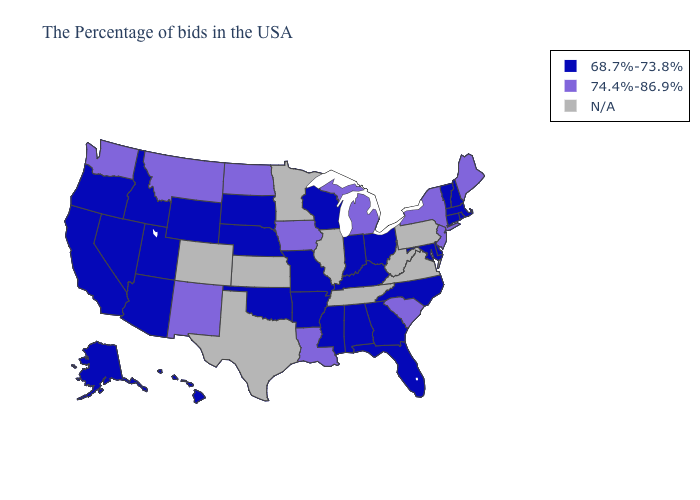Among the states that border South Dakota , which have the highest value?
Give a very brief answer. Iowa, North Dakota, Montana. Name the states that have a value in the range 68.7%-73.8%?
Be succinct. Massachusetts, Rhode Island, New Hampshire, Vermont, Connecticut, Delaware, Maryland, North Carolina, Ohio, Florida, Georgia, Kentucky, Indiana, Alabama, Wisconsin, Mississippi, Missouri, Arkansas, Nebraska, Oklahoma, South Dakota, Wyoming, Utah, Arizona, Idaho, Nevada, California, Oregon, Alaska, Hawaii. Among the states that border Florida , which have the lowest value?
Concise answer only. Georgia, Alabama. Does Nebraska have the highest value in the MidWest?
Short answer required. No. Name the states that have a value in the range N/A?
Quick response, please. Pennsylvania, Virginia, West Virginia, Tennessee, Illinois, Minnesota, Kansas, Texas, Colorado. Is the legend a continuous bar?
Write a very short answer. No. Which states have the highest value in the USA?
Give a very brief answer. Maine, New York, New Jersey, South Carolina, Michigan, Louisiana, Iowa, North Dakota, New Mexico, Montana, Washington. Which states hav the highest value in the Northeast?
Short answer required. Maine, New York, New Jersey. Name the states that have a value in the range N/A?
Quick response, please. Pennsylvania, Virginia, West Virginia, Tennessee, Illinois, Minnesota, Kansas, Texas, Colorado. What is the lowest value in the USA?
Quick response, please. 68.7%-73.8%. Does New York have the lowest value in the USA?
Keep it brief. No. What is the value of New Jersey?
Quick response, please. 74.4%-86.9%. Name the states that have a value in the range N/A?
Short answer required. Pennsylvania, Virginia, West Virginia, Tennessee, Illinois, Minnesota, Kansas, Texas, Colorado. What is the value of Tennessee?
Keep it brief. N/A. 